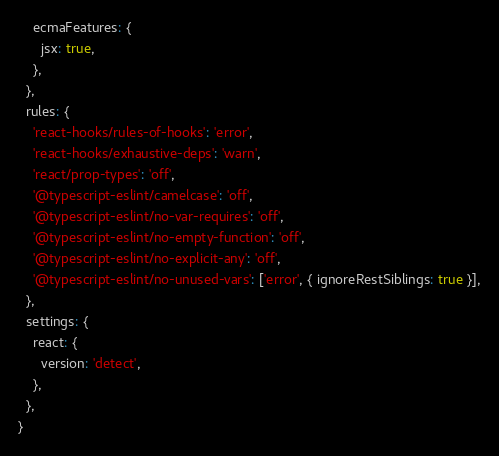<code> <loc_0><loc_0><loc_500><loc_500><_JavaScript_>    ecmaFeatures: {
      jsx: true,
    },
  },
  rules: {
    'react-hooks/rules-of-hooks': 'error',
    'react-hooks/exhaustive-deps': 'warn',
    'react/prop-types': 'off',
    '@typescript-eslint/camelcase': 'off',
    '@typescript-eslint/no-var-requires': 'off',
    '@typescript-eslint/no-empty-function': 'off',
    '@typescript-eslint/no-explicit-any': 'off',
    '@typescript-eslint/no-unused-vars': ['error', { ignoreRestSiblings: true }],
  },
  settings: {
    react: {
      version: 'detect',
    },
  },
}
</code> 